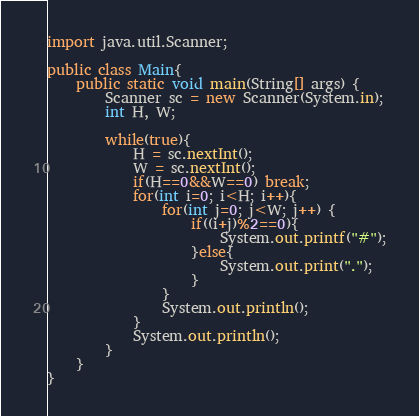<code> <loc_0><loc_0><loc_500><loc_500><_Java_>import java.util.Scanner;

public class Main{
	public static void main(String[] args) {
		Scanner sc = new Scanner(System.in);
		int H, W;

		while(true){
			H = sc.nextInt();
			W = sc.nextInt();
			if(H==0&&W==0) break;
			for(int i=0; i<H; i++){
				for(int j=0; j<W; j++) {
					if((i+j)%2==0){
						System.out.printf("#");
					}else{
						System.out.print(".");
					}
				}
				System.out.println();
			}
			System.out.println();
		}
	}
}</code> 